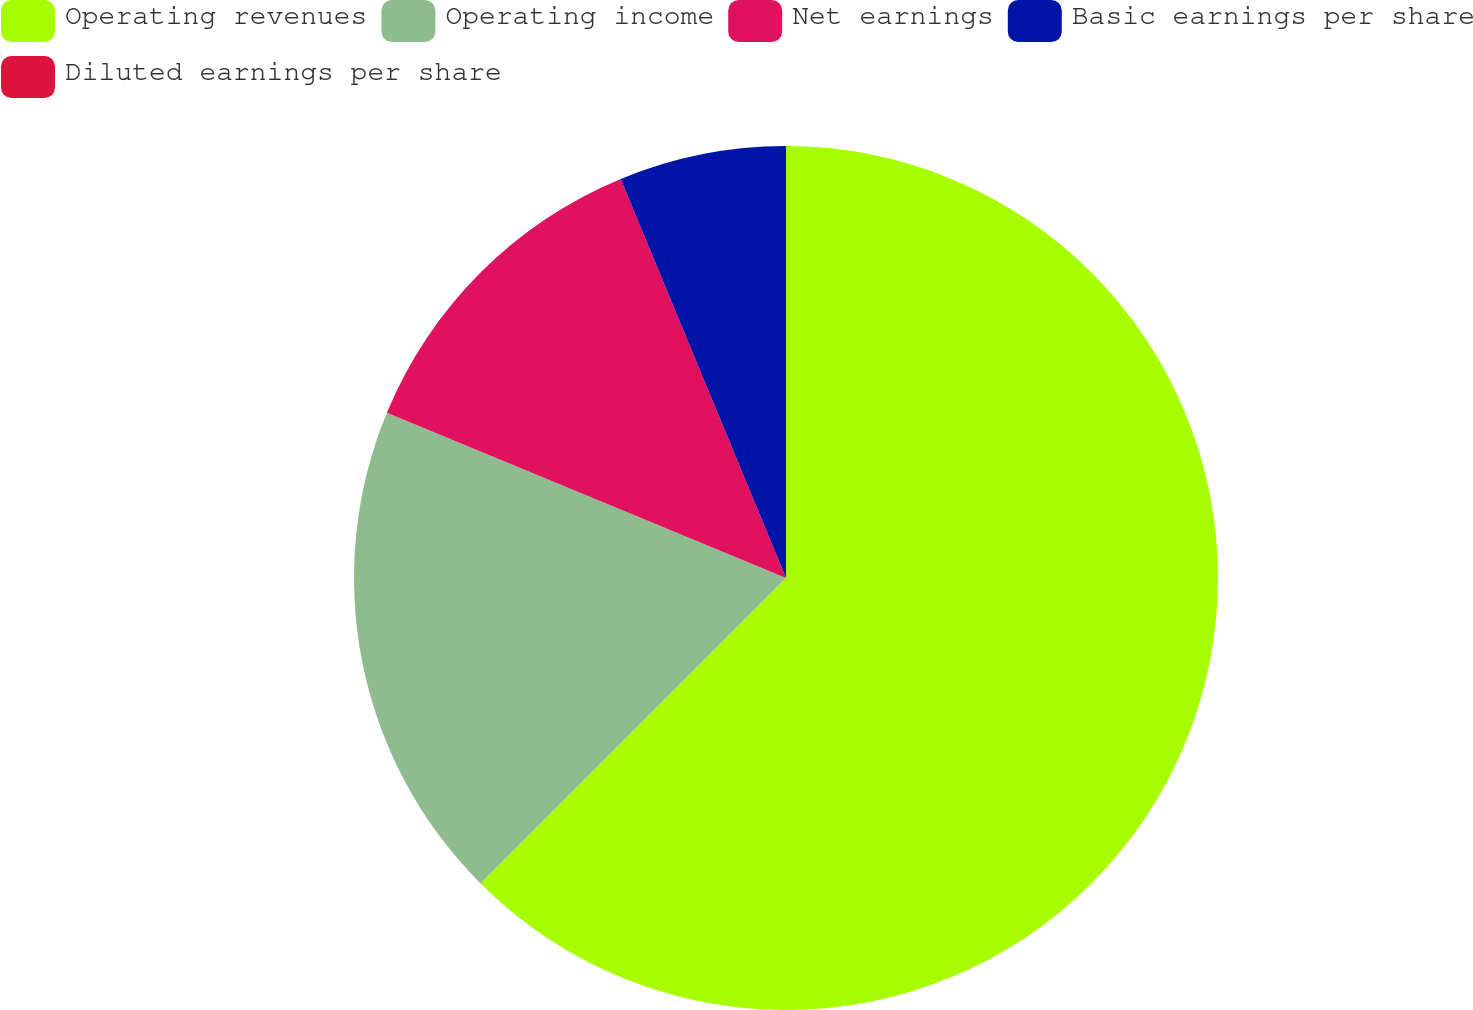Convert chart to OTSL. <chart><loc_0><loc_0><loc_500><loc_500><pie_chart><fcel>Operating revenues<fcel>Operating income<fcel>Net earnings<fcel>Basic earnings per share<fcel>Diluted earnings per share<nl><fcel>62.5%<fcel>18.75%<fcel>12.5%<fcel>6.25%<fcel>0.0%<nl></chart> 